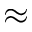Convert formula to latex. <formula><loc_0><loc_0><loc_500><loc_500>\approx</formula> 